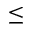Convert formula to latex. <formula><loc_0><loc_0><loc_500><loc_500>\leq</formula> 